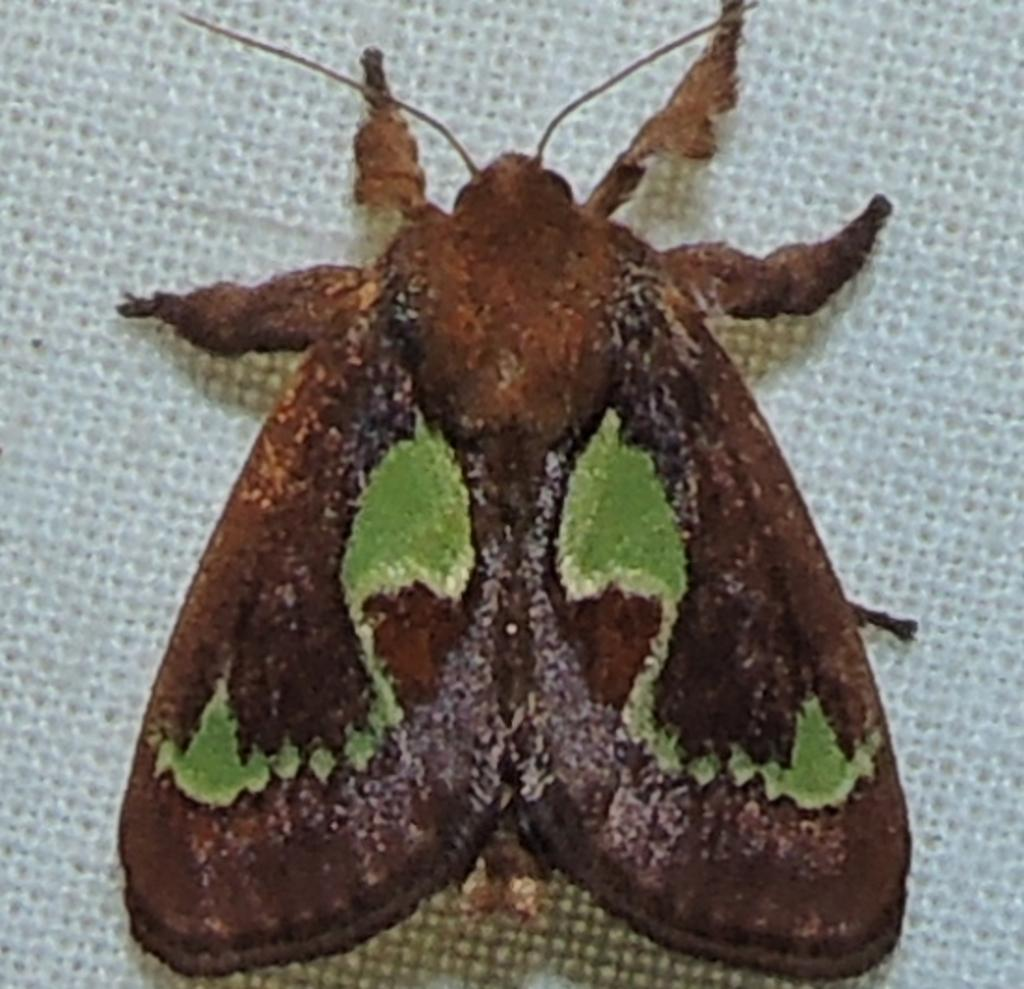What is the color of the main object in the image? The main object in the image is white. What can be seen on the white object? There is a brown and green insect on the white object. Are there any snakes visible in the image? No, there are no snakes present in the image. What season is depicted in the image, given the presence of horses and winter? The image does not depict any horses or winter; it only features a white object with a brown and green insect on it. 